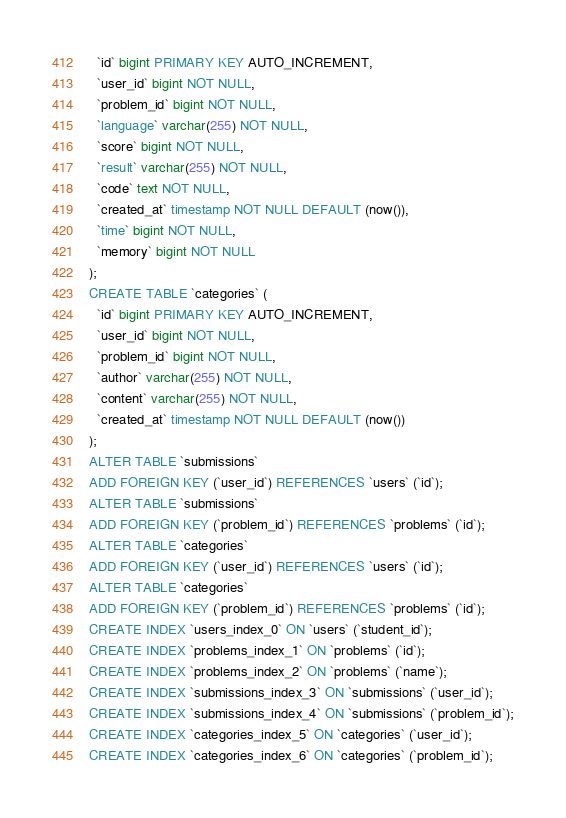Convert code to text. <code><loc_0><loc_0><loc_500><loc_500><_SQL_>  `id` bigint PRIMARY KEY AUTO_INCREMENT,
  `user_id` bigint NOT NULL,
  `problem_id` bigint NOT NULL,
  `language` varchar(255) NOT NULL,
  `score` bigint NOT NULL,
  `result` varchar(255) NOT NULL,
  `code` text NOT NULL,
  `created_at` timestamp NOT NULL DEFAULT (now()),
  `time` bigint NOT NULL,
  `memory` bigint NOT NULL
);
CREATE TABLE `categories` (
  `id` bigint PRIMARY KEY AUTO_INCREMENT,
  `user_id` bigint NOT NULL,
  `problem_id` bigint NOT NULL,
  `author` varchar(255) NOT NULL,
  `content` varchar(255) NOT NULL,
  `created_at` timestamp NOT NULL DEFAULT (now())
);
ALTER TABLE `submissions`
ADD FOREIGN KEY (`user_id`) REFERENCES `users` (`id`);
ALTER TABLE `submissions`
ADD FOREIGN KEY (`problem_id`) REFERENCES `problems` (`id`);
ALTER TABLE `categories`
ADD FOREIGN KEY (`user_id`) REFERENCES `users` (`id`);
ALTER TABLE `categories`
ADD FOREIGN KEY (`problem_id`) REFERENCES `problems` (`id`);
CREATE INDEX `users_index_0` ON `users` (`student_id`);
CREATE INDEX `problems_index_1` ON `problems` (`id`);
CREATE INDEX `problems_index_2` ON `problems` (`name`);
CREATE INDEX `submissions_index_3` ON `submissions` (`user_id`);
CREATE INDEX `submissions_index_4` ON `submissions` (`problem_id`);
CREATE INDEX `categories_index_5` ON `categories` (`user_id`);
CREATE INDEX `categories_index_6` ON `categories` (`problem_id`);</code> 